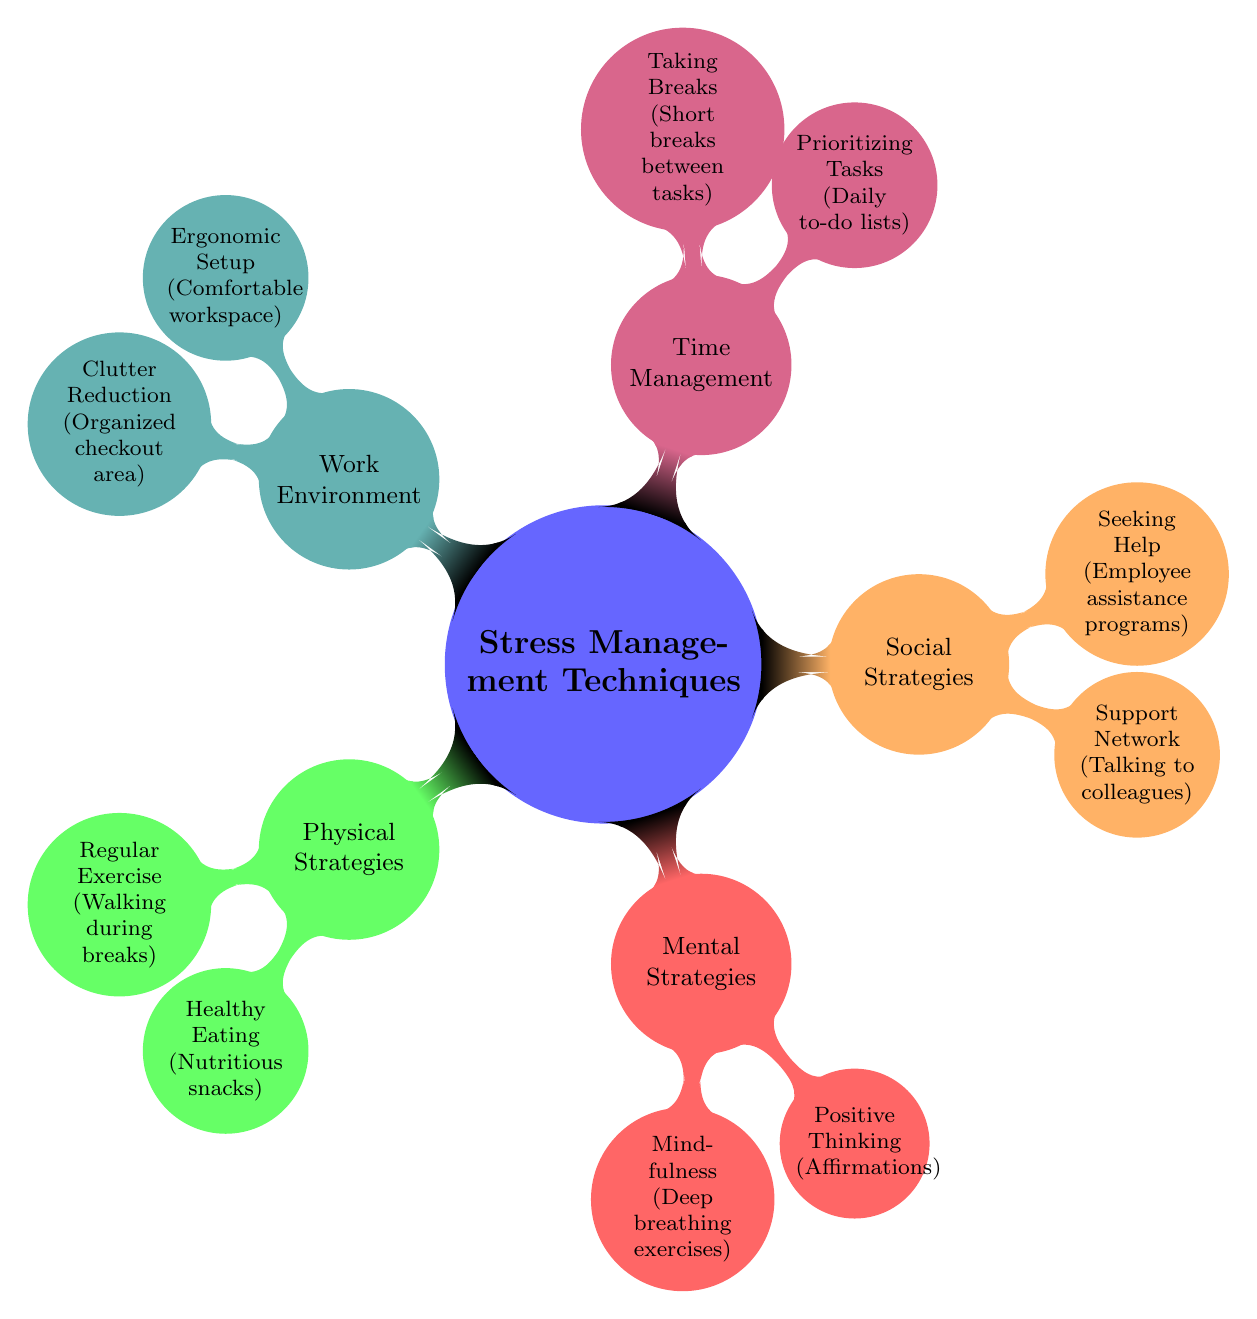What is the main category of strategies presented in the diagram? The diagram's central node is labeled "Stress Management Techniques," indicating that this is the primary category.
Answer: Stress Management Techniques How many strategies are listed under Physical Strategies? Under the "Physical Strategies" node, there are two child nodes: "Regular Exercise" and "Healthy Eating." Thus, the count is 2.
Answer: 2 What is one technique included in the Mental Strategies category? Among the child nodes under "Mental Strategies," one example is "Mindfulness," which includes "Deep breathing exercises."
Answer: Mindfulness How are the strategies categorized in the diagram? The diagram categorizes strategies into five main types: Physical Strategies, Mental Strategies, Social Strategies, Time Management, and Work Environment.
Answer: Five What is associated with the "Support Network" strategy? The "Support Network" node has "Talking to colleagues" as its child node explaining the technique associated with it.
Answer: Talking to colleagues Which strategy is related to reducing clutter? The phrase "Clutter Reduction" belongs to the "Work Environment" category, indicating its relation to managing clutter.
Answer: Clutter Reduction Which strategy focuses on task organization? The node "Prioritizing Tasks" clearly indicates that it focuses on organizing daily responsibilities effectively.
Answer: Prioritizing Tasks What mindfulness technique is mentioned for stress management? The diagram specifies "Deep breathing exercises" as a technique related to the mindfulness strategy under Mental Strategies.
Answer: Deep breathing exercises What is an example of a social strategy included in the diagram? The "Seeking Help" node provides "Employee assistance programs" as an example of a social strategy aimed at stress management.
Answer: Employee assistance programs 